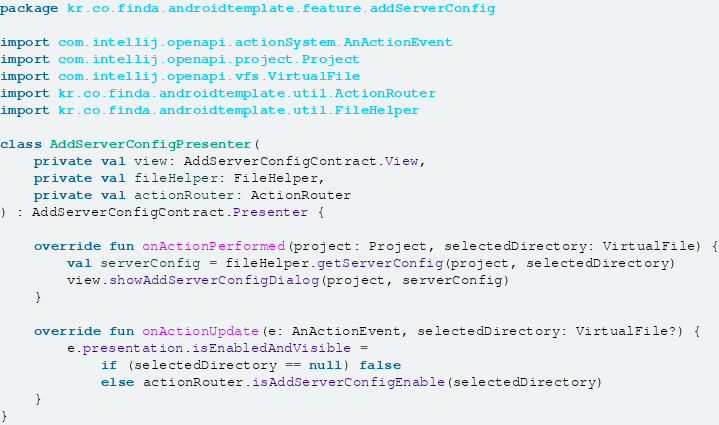Convert code to text. <code><loc_0><loc_0><loc_500><loc_500><_Kotlin_>package kr.co.finda.androidtemplate.feature.addServerConfig

import com.intellij.openapi.actionSystem.AnActionEvent
import com.intellij.openapi.project.Project
import com.intellij.openapi.vfs.VirtualFile
import kr.co.finda.androidtemplate.util.ActionRouter
import kr.co.finda.androidtemplate.util.FileHelper

class AddServerConfigPresenter(
    private val view: AddServerConfigContract.View,
    private val fileHelper: FileHelper,
    private val actionRouter: ActionRouter
) : AddServerConfigContract.Presenter {

    override fun onActionPerformed(project: Project, selectedDirectory: VirtualFile) {
        val serverConfig = fileHelper.getServerConfig(project, selectedDirectory)
        view.showAddServerConfigDialog(project, serverConfig)
    }

    override fun onActionUpdate(e: AnActionEvent, selectedDirectory: VirtualFile?) {
        e.presentation.isEnabledAndVisible =
            if (selectedDirectory == null) false
            else actionRouter.isAddServerConfigEnable(selectedDirectory)
    }
}</code> 